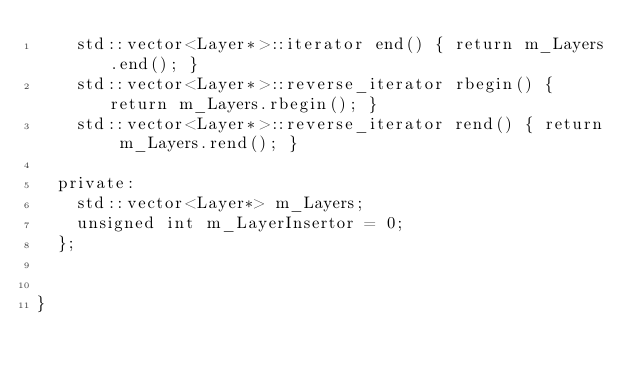Convert code to text. <code><loc_0><loc_0><loc_500><loc_500><_C_>		std::vector<Layer*>::iterator end() { return m_Layers.end(); }
		std::vector<Layer*>::reverse_iterator rbegin() { return m_Layers.rbegin(); }
		std::vector<Layer*>::reverse_iterator rend() { return m_Layers.rend(); }

	private:
		std::vector<Layer*> m_Layers;
		unsigned int m_LayerInsertor = 0;
	};

	
}</code> 